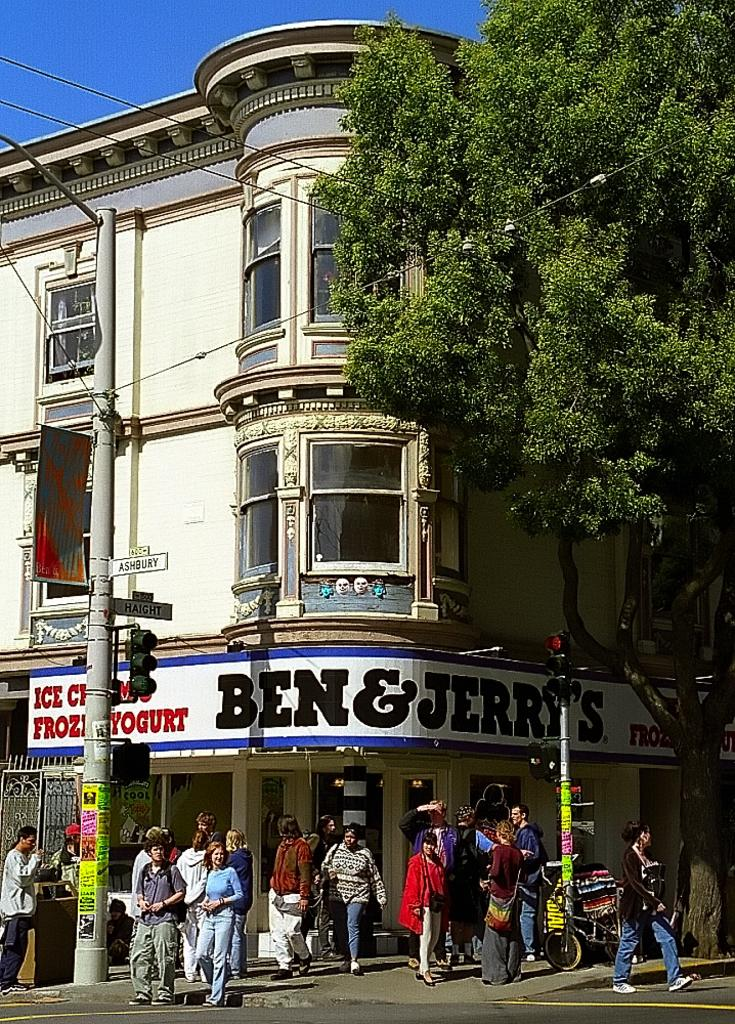Provide a one-sentence caption for the provided image. A number of people mill about a street corner on a sunny day in front of a Ben and Jerry's store. 